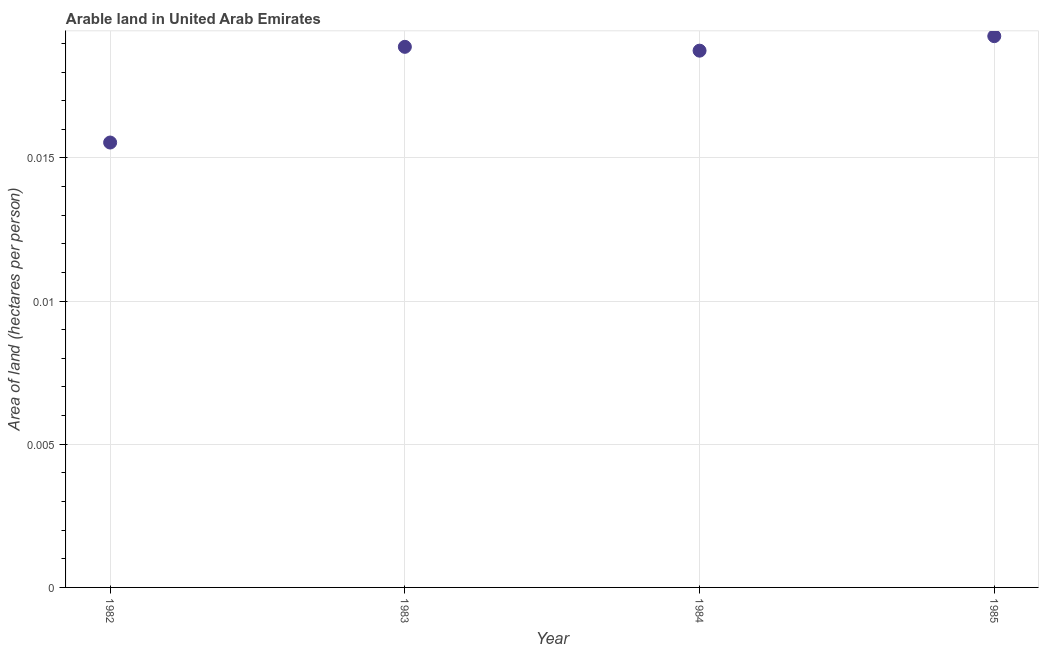What is the area of arable land in 1984?
Make the answer very short. 0.02. Across all years, what is the maximum area of arable land?
Keep it short and to the point. 0.02. Across all years, what is the minimum area of arable land?
Your answer should be very brief. 0.02. In which year was the area of arable land maximum?
Ensure brevity in your answer.  1985. What is the sum of the area of arable land?
Offer a very short reply. 0.07. What is the difference between the area of arable land in 1984 and 1985?
Your answer should be very brief. -0. What is the average area of arable land per year?
Provide a short and direct response. 0.02. What is the median area of arable land?
Your answer should be compact. 0.02. What is the ratio of the area of arable land in 1983 to that in 1984?
Your answer should be compact. 1.01. What is the difference between the highest and the second highest area of arable land?
Your answer should be compact. 0. What is the difference between the highest and the lowest area of arable land?
Keep it short and to the point. 0. How many years are there in the graph?
Make the answer very short. 4. What is the difference between two consecutive major ticks on the Y-axis?
Your response must be concise. 0.01. Are the values on the major ticks of Y-axis written in scientific E-notation?
Keep it short and to the point. No. Does the graph contain grids?
Your response must be concise. Yes. What is the title of the graph?
Make the answer very short. Arable land in United Arab Emirates. What is the label or title of the X-axis?
Your response must be concise. Year. What is the label or title of the Y-axis?
Keep it short and to the point. Area of land (hectares per person). What is the Area of land (hectares per person) in 1982?
Keep it short and to the point. 0.02. What is the Area of land (hectares per person) in 1983?
Offer a very short reply. 0.02. What is the Area of land (hectares per person) in 1984?
Give a very brief answer. 0.02. What is the Area of land (hectares per person) in 1985?
Provide a short and direct response. 0.02. What is the difference between the Area of land (hectares per person) in 1982 and 1983?
Provide a succinct answer. -0. What is the difference between the Area of land (hectares per person) in 1982 and 1984?
Ensure brevity in your answer.  -0. What is the difference between the Area of land (hectares per person) in 1982 and 1985?
Your answer should be compact. -0. What is the difference between the Area of land (hectares per person) in 1983 and 1984?
Your answer should be compact. 0. What is the difference between the Area of land (hectares per person) in 1983 and 1985?
Offer a very short reply. -0. What is the difference between the Area of land (hectares per person) in 1984 and 1985?
Offer a terse response. -0. What is the ratio of the Area of land (hectares per person) in 1982 to that in 1983?
Offer a very short reply. 0.82. What is the ratio of the Area of land (hectares per person) in 1982 to that in 1984?
Provide a succinct answer. 0.83. What is the ratio of the Area of land (hectares per person) in 1982 to that in 1985?
Your answer should be compact. 0.81. What is the ratio of the Area of land (hectares per person) in 1984 to that in 1985?
Provide a succinct answer. 0.97. 